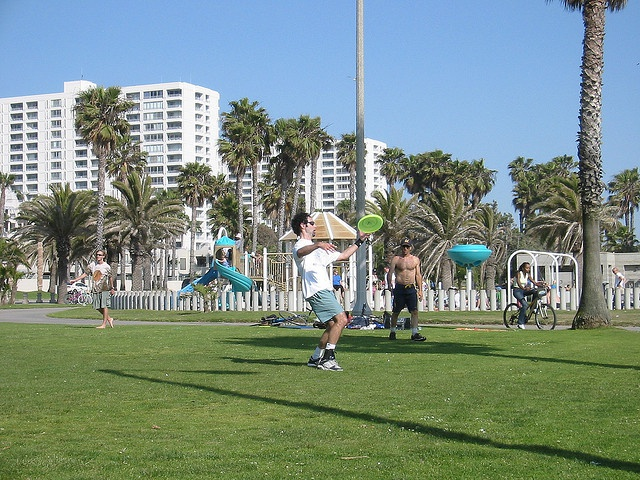Describe the objects in this image and their specific colors. I can see people in darkgray, white, black, and gray tones, people in darkgray, black, gray, and tan tones, bicycle in darkgray, black, and gray tones, people in darkgray, gray, lightgray, and tan tones, and people in darkgray, black, gray, and white tones in this image. 